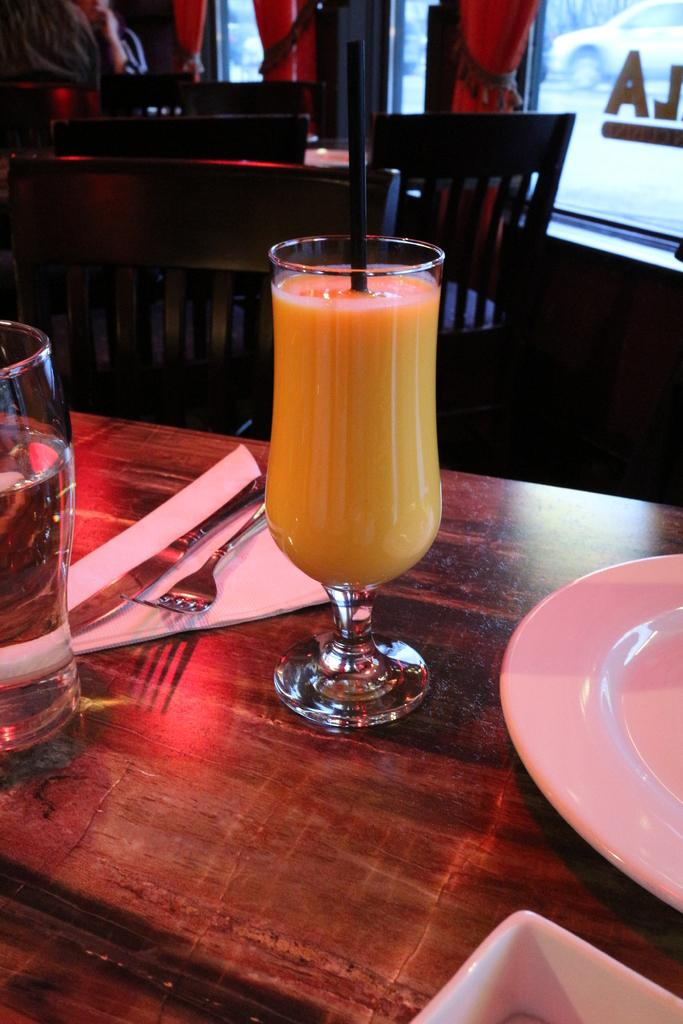What objects are on the table in the image? There are glasses, a plate, and spoons on the table in the image. What can be seen in the background of the image? There are chairs and curtains in the background. Is there any transportation visible in the image? Yes, there is a car visible in the image. What type of hair can be seen on the car in the image? There is no hair visible on the car in the image; it is a vehicle, not a living being. 